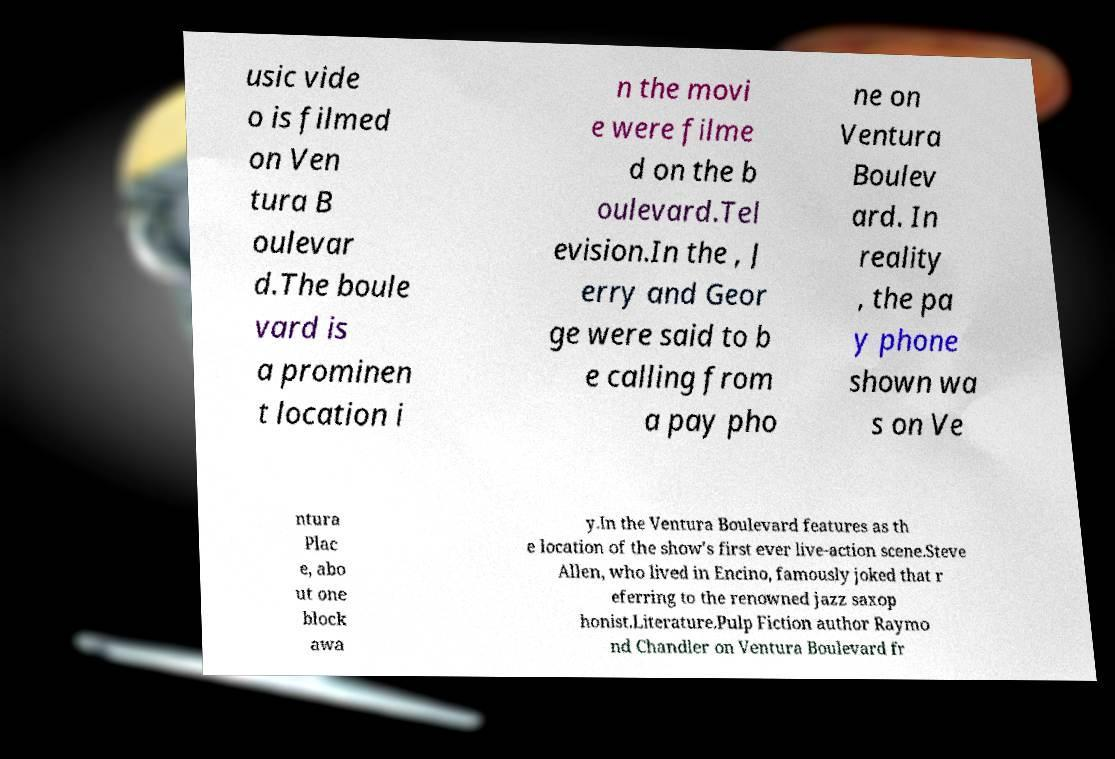Could you assist in decoding the text presented in this image and type it out clearly? usic vide o is filmed on Ven tura B oulevar d.The boule vard is a prominen t location i n the movi e were filme d on the b oulevard.Tel evision.In the , J erry and Geor ge were said to b e calling from a pay pho ne on Ventura Boulev ard. In reality , the pa y phone shown wa s on Ve ntura Plac e, abo ut one block awa y.In the Ventura Boulevard features as th e location of the show's first ever live-action scene.Steve Allen, who lived in Encino, famously joked that r eferring to the renowned jazz saxop honist.Literature.Pulp Fiction author Raymo nd Chandler on Ventura Boulevard fr 